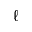Convert formula to latex. <formula><loc_0><loc_0><loc_500><loc_500>\ell</formula> 